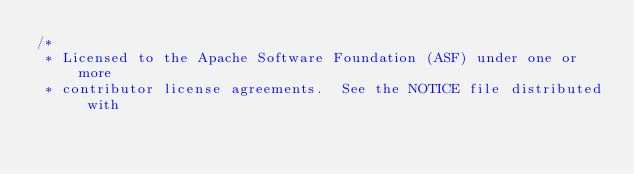<code> <loc_0><loc_0><loc_500><loc_500><_Java_>/*
 * Licensed to the Apache Software Foundation (ASF) under one or more
 * contributor license agreements.  See the NOTICE file distributed with</code> 